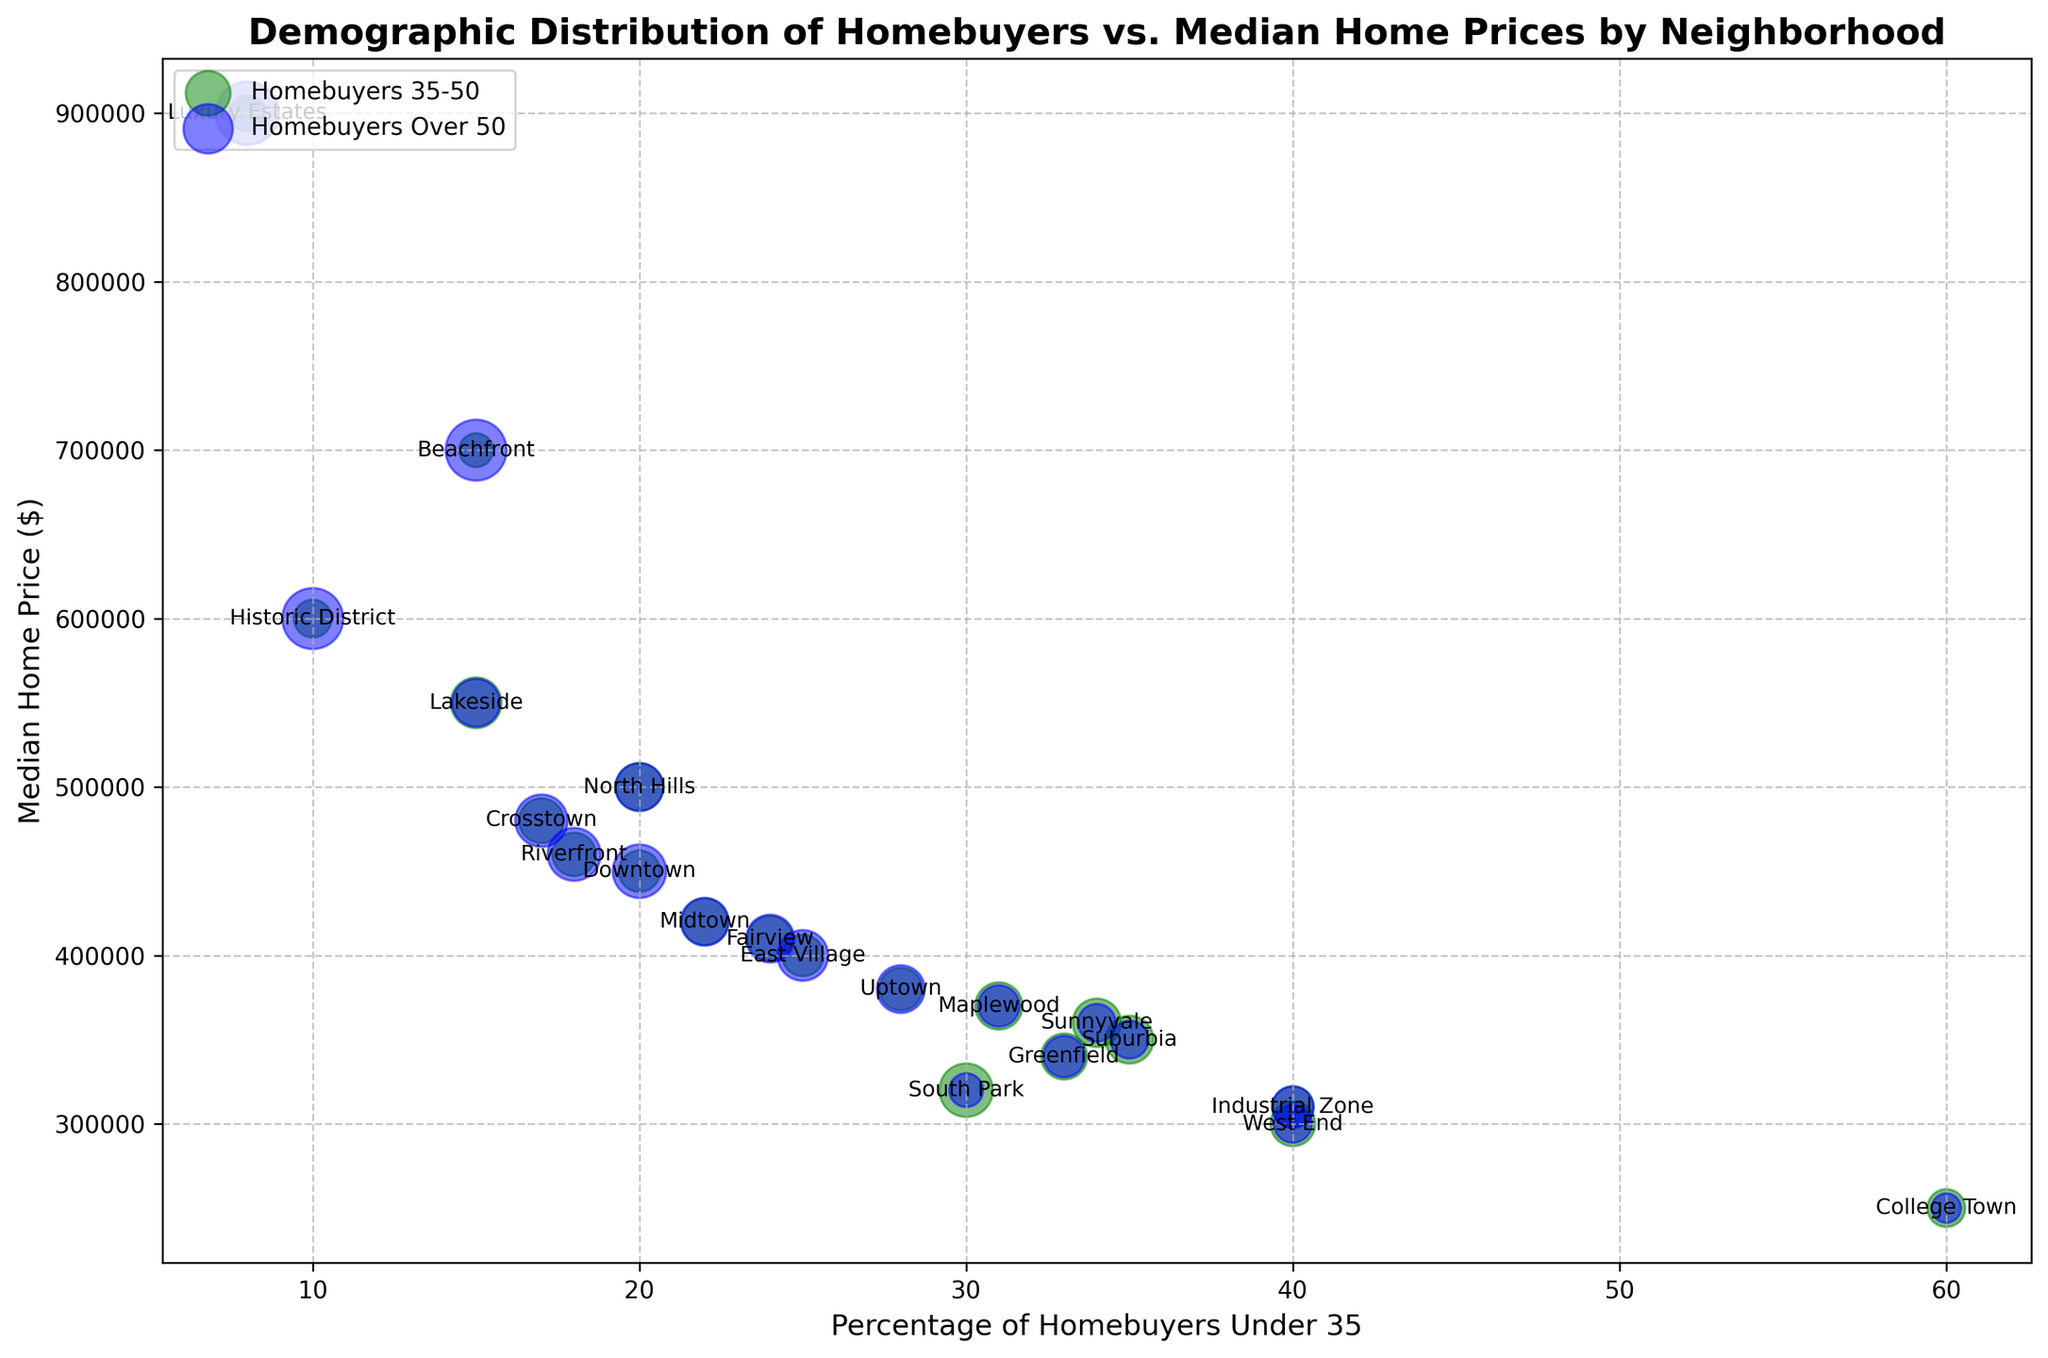Which neighborhood has the highest median home price? By visually inspecting the y-axis, the highest bubble corresponds to "Luxury Estates" with a median home price of $900,000.
Answer: Luxury Estates What percentage of homebuyers are under 35 in both College Town and West End combined? College Town has 60% and West End has 40% of homebuyers under 35. Summing these up, 60% + 40% = 100%.
Answer: 100% Which neighborhood has the smallest bubble size for homebuyers Over 50? The smallest bubbles for homebuyers over 50 can be visually identified. These are present in College Town.
Answer: College Town Which neighborhood has a higher median home price, Lakeside or North Hills? Comparing the vertical positions of "Lakeside" and "North Hills" bubbles, Lakeside (y-axis: $550,000) is higher than North Hills ($500,000).
Answer: Lakeside Do more homebuyers fall into the 35-50 age group or Over 50 age group in Downtown? Inspecting the green (35-50) and blue (Over 50) bubbles for Downtown, the Over 50 bubble is larger, indicating a larger percentage.
Answer: Over 50 Which neighborhood has the closest median home price to the overall average? Average median price = (Sum of all prices / Number of neighborhoods). Calculate each price manually: (450000 + 350000 + 550000 + 600000 + 300000 + 400000 + 500000 + 320000 + 420000 + 700000 + 380000 + 340000 + 410000 + 460000 + 310000 + 250000 + 900000 + 370000 + 360000 + 480000) / 20 = 434500. Match it visually, closest to 434500 is Riverfront at $460,000 or Midtown at $420,000.
Answer: Riverfront Which group is more prevalent among homebuyers aged 35-50, Suburbia or Sunnyvale? Comparing the sizes of green bubbles representing ages 35-50, Sunnyvale is larger with 41%, compared to Suburbia's 40%.
Answer: Sunnyvale Is there a trend associated with higher median home prices and the percentage of homebuyers Over 50? Observing that neighborhoods with higher home prices, such as Luxury Estates and Historic District, have larger blue bubbles indicating higher percentages of homebuyers Over 50.
Answer: Yes What is the median home price difference between Uptown and Suburbia? Subtract the median price of Suburbia ($350,000) from Uptown ($380,000): $380,000 - $350,000 = $30,000.
Answer: $30,000 Which neighborhoods have homebuyers under 35 making up at least 30% of the total? Identifiable by inspecting the x-axis, Suburbia (35%), West End (40%), South Park (30%), Industrial Zone (40%), College Town (60%), Greenfield (33%), Sunnyvale (34%), and Maplewood (31%) fulfill this criteria.
Answer: Suburbia, West End, South Park, Industrial Zone, College Town, Greenfield, Sunnyvale, Maplewood 